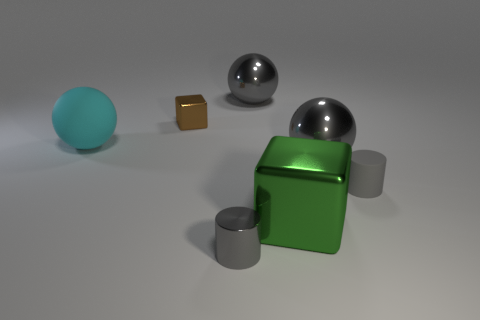Add 1 large purple cylinders. How many objects exist? 8 Subtract all cylinders. How many objects are left? 5 Add 7 small rubber cylinders. How many small rubber cylinders exist? 8 Subtract 0 red cylinders. How many objects are left? 7 Subtract all tiny red cylinders. Subtract all large gray metallic balls. How many objects are left? 5 Add 2 large green metal things. How many large green metal things are left? 3 